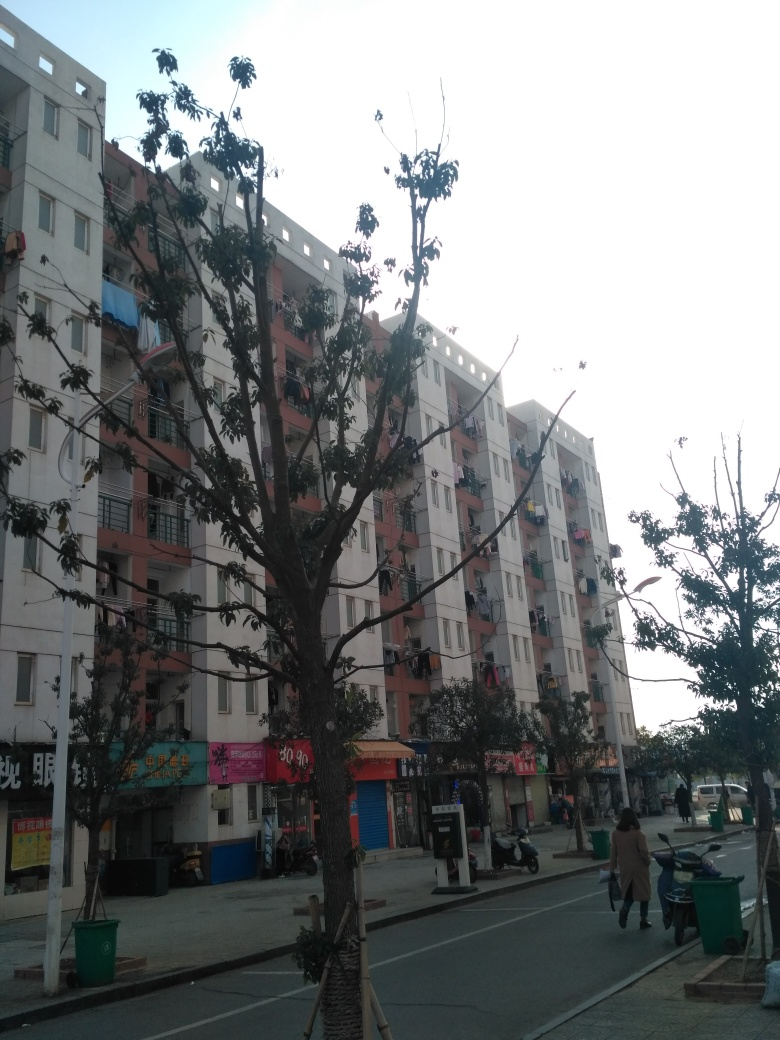How is the composition of the image?
A. Messy
B. Average
C. Quite suitable
Answer with the option's letter from the given choices directly.
 C. 